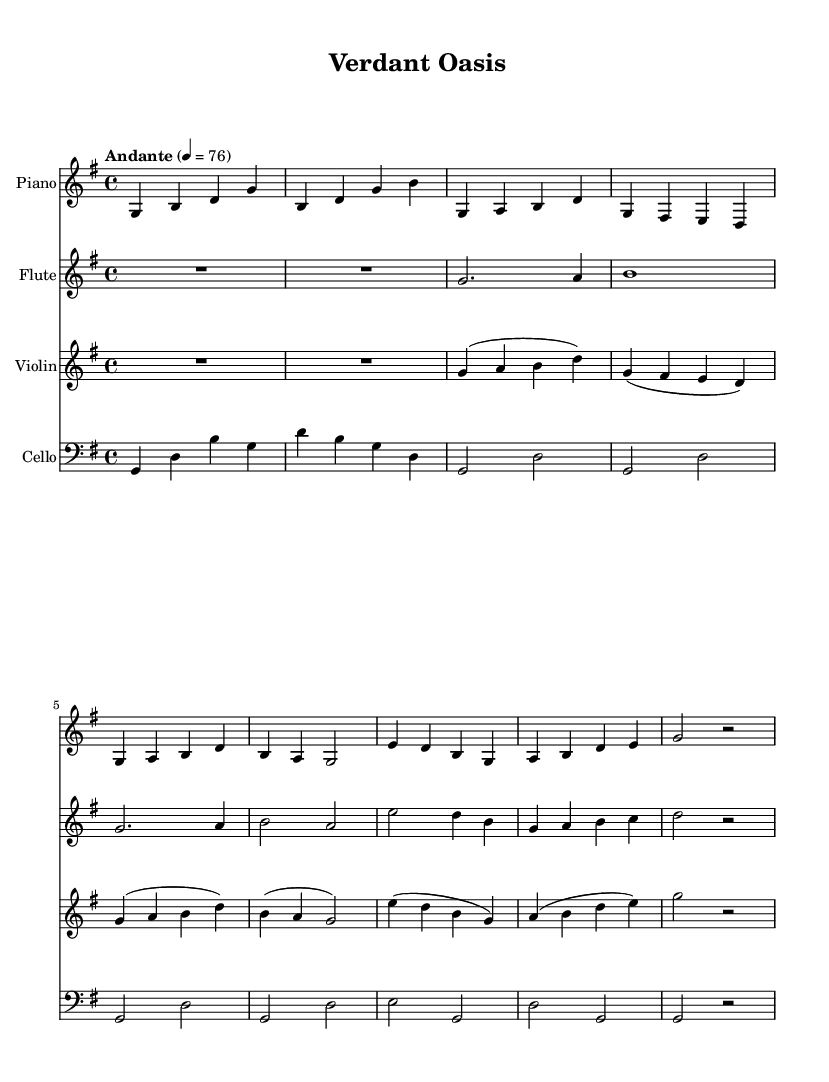What is the key signature of this music? The key signature is G major, which has one sharp (F#). The key signature is indicated at the beginning of the staff lines and shows that F is raised by a half step.
Answer: G major What is the time signature of this piece? The time signature is 4/4, which is indicated at the beginning of the sheet music. This means there are four beats in each measure and that the quarter note gets one beat.
Answer: 4/4 What is the tempo marking? The tempo marking is "Andante," which indicates a moderately slow tempo. The marking is specified above the staff and accompanied by a metronome marking of 76 beats per minute.
Answer: Andante How many instruments are featured in this piece? There are four instruments featured: Piano, Flute, Violin, and Cello. The instruments are labeled at the beginning of each staff.
Answer: Four What note does the flute start on? The flute starts on the note G. This can be determined by looking at the first note in the flute staff, which is notated as a G in the second octave.
Answer: G Which two instruments have a rest at the beginning? The Piano and Flute both have a rest at the beginning. In the staff notation, they are represented by "R" symbols, indicating a pause before the first note is played.
Answer: Piano and Flute How many measures does the flute part have in total? The flute part has a total of six measures. This can be counted by examining the vertical bar lines that separate each measure in the flute staff.
Answer: Six 